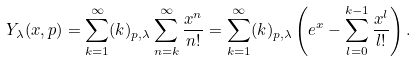<formula> <loc_0><loc_0><loc_500><loc_500>Y _ { \lambda } ( x , p ) = \sum _ { k = 1 } ^ { \infty } ( k ) _ { p , \lambda } \sum _ { n = k } ^ { \infty } \frac { x ^ { n } } { n ! } = \sum _ { k = 1 } ^ { \infty } ( k ) _ { p , \lambda } \left ( e ^ { x } - \sum _ { l = 0 } ^ { k - 1 } \frac { x ^ { l } } { l ! } \right ) .</formula> 